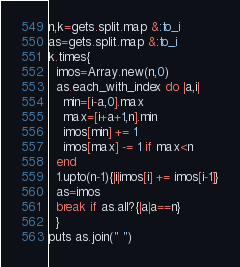Convert code to text. <code><loc_0><loc_0><loc_500><loc_500><_Ruby_>n,k=gets.split.map &:to_i
as=gets.split.map &:to_i
k.times{
  imos=Array.new(n,0)
  as.each_with_index do |a,i|
    min=[i-a,0].max
    max=[i+a+1,n].min
    imos[min] += 1
    imos[max] -= 1 if max<n
  end
  1.upto(n-1){|i|imos[i] += imos[i-1]}
  as=imos
  break if as.all?{|a|a==n}
  }
puts as.join(" ")</code> 